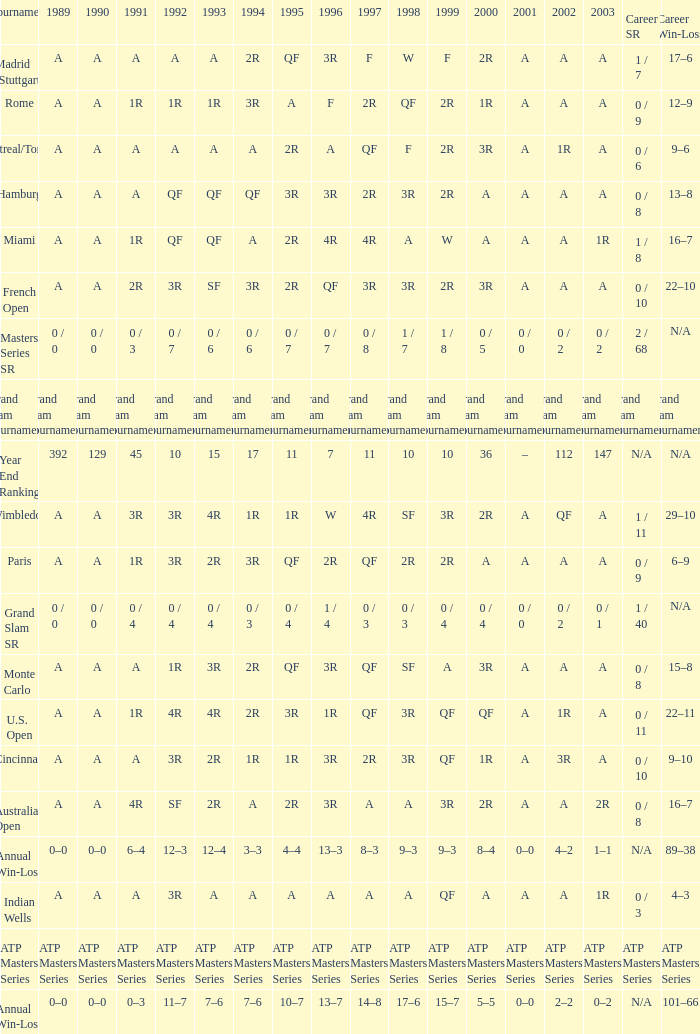What was the value in 1989 with QF in 1997 and A in 1993? A. 